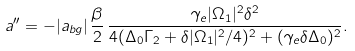Convert formula to latex. <formula><loc_0><loc_0><loc_500><loc_500>a ^ { \prime \prime } = - | a _ { b g } | \, \frac { \beta } { 2 } \, \frac { \gamma _ { e } | \Omega _ { 1 } | ^ { 2 } \delta ^ { 2 } } { 4 ( \Delta _ { 0 } \Gamma _ { 2 } + \delta | \Omega _ { 1 } | ^ { 2 } / 4 ) ^ { 2 } + ( \gamma _ { e } \delta \Delta _ { 0 } ) ^ { 2 } } .</formula> 